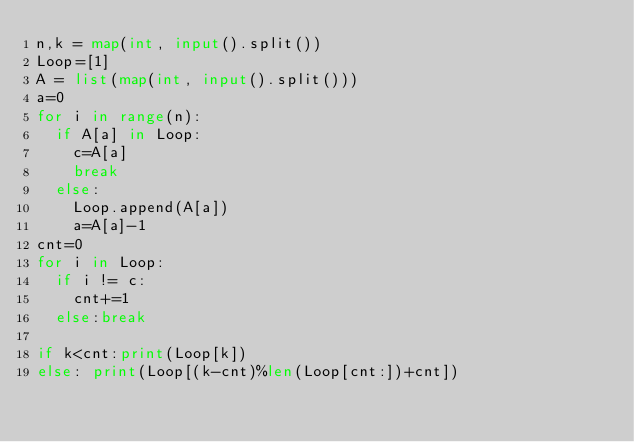Convert code to text. <code><loc_0><loc_0><loc_500><loc_500><_Python_>n,k = map(int, input().split())
Loop=[1]
A = list(map(int, input().split()))
a=0
for i in range(n):
  if A[a] in Loop:
    c=A[a]
    break
  else:
    Loop.append(A[a])
    a=A[a]-1
cnt=0
for i in Loop:
  if i != c:
    cnt+=1
  else:break

if k<cnt:print(Loop[k])
else: print(Loop[(k-cnt)%len(Loop[cnt:])+cnt])
</code> 